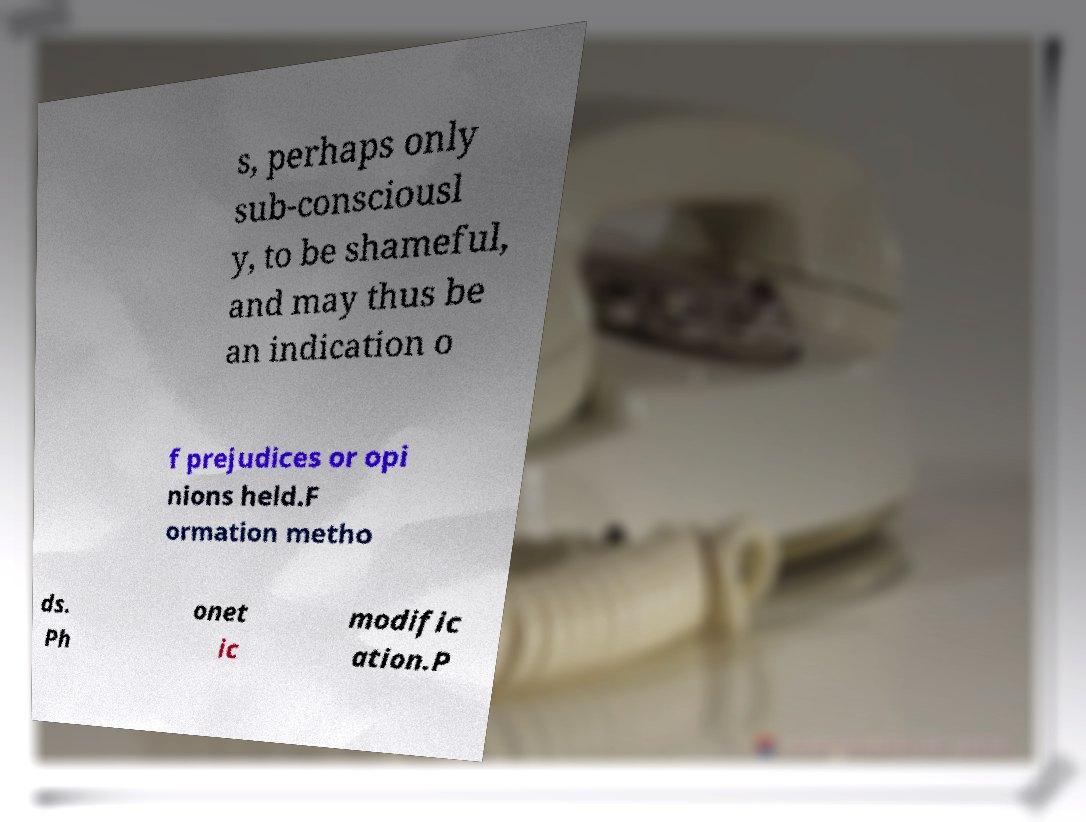Please identify and transcribe the text found in this image. s, perhaps only sub-consciousl y, to be shameful, and may thus be an indication o f prejudices or opi nions held.F ormation metho ds. Ph onet ic modific ation.P 